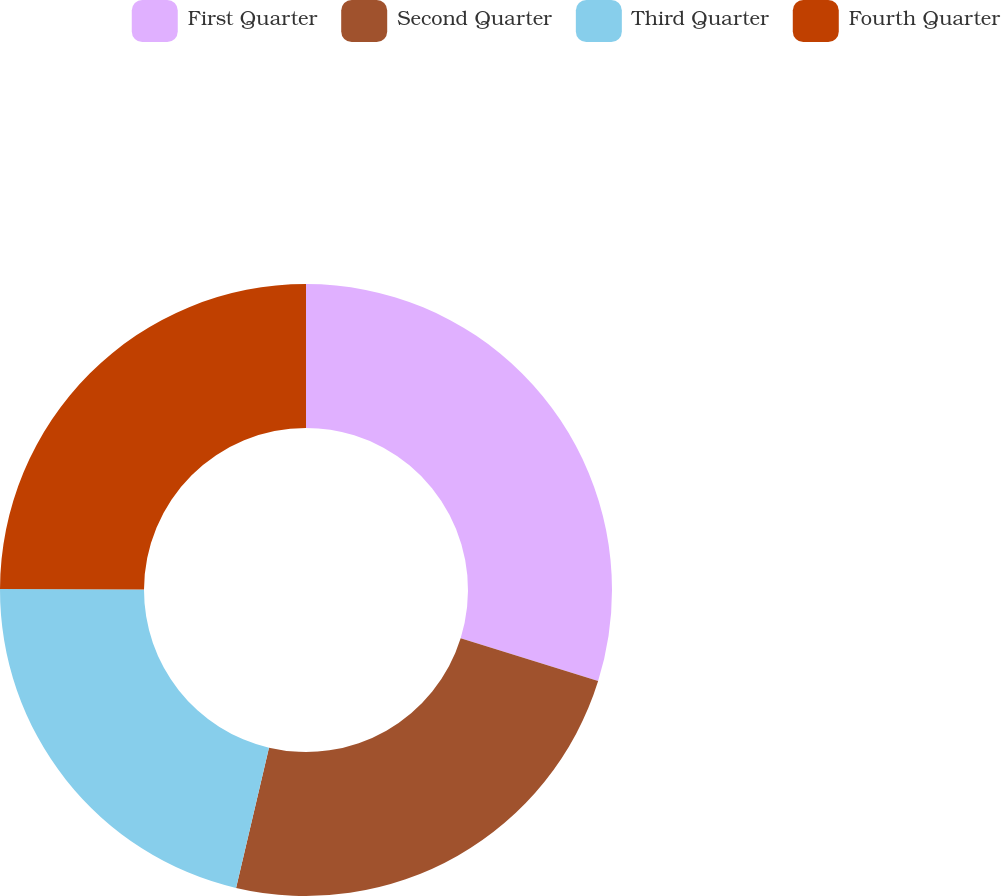Convert chart. <chart><loc_0><loc_0><loc_500><loc_500><pie_chart><fcel>First Quarter<fcel>Second Quarter<fcel>Third Quarter<fcel>Fourth Quarter<nl><fcel>29.81%<fcel>23.86%<fcel>21.38%<fcel>24.95%<nl></chart> 